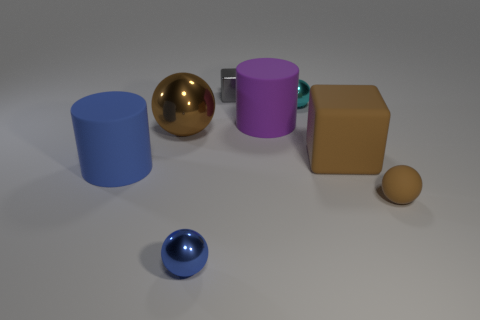Are there any small blue metal things that are to the left of the large cylinder in front of the big brown cube?
Keep it short and to the point. No. The tiny object that is both in front of the large blue thing and behind the blue sphere is what color?
Provide a succinct answer. Brown. What is the size of the cyan object?
Your answer should be compact. Small. What number of blue spheres are the same size as the shiny cube?
Offer a very short reply. 1. Does the cylinder on the left side of the large brown metallic object have the same material as the cyan sphere behind the brown shiny ball?
Offer a very short reply. No. What material is the blue object that is in front of the rubber cylinder on the left side of the blue shiny sphere?
Provide a succinct answer. Metal. What is the big object on the right side of the purple cylinder made of?
Your response must be concise. Rubber. What number of small brown things are the same shape as the blue shiny object?
Give a very brief answer. 1. Is the color of the big cube the same as the large ball?
Your answer should be compact. Yes. There is a big cylinder behind the matte cylinder that is in front of the brown rubber thing behind the large blue matte cylinder; what is it made of?
Give a very brief answer. Rubber. 